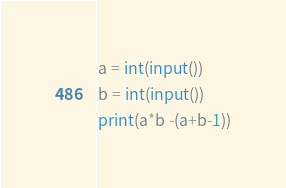Convert code to text. <code><loc_0><loc_0><loc_500><loc_500><_Python_>a = int(input())
b = int(input())
print(a*b -(a+b-1))</code> 